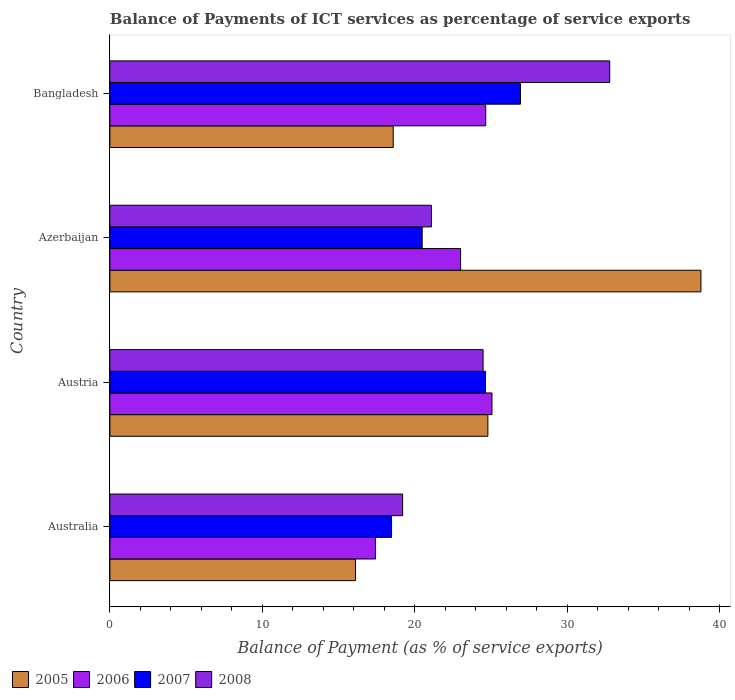How many different coloured bars are there?
Provide a succinct answer. 4. How many groups of bars are there?
Your response must be concise. 4. Are the number of bars per tick equal to the number of legend labels?
Give a very brief answer. Yes. How many bars are there on the 3rd tick from the bottom?
Give a very brief answer. 4. What is the label of the 1st group of bars from the top?
Give a very brief answer. Bangladesh. In how many cases, is the number of bars for a given country not equal to the number of legend labels?
Offer a very short reply. 0. What is the balance of payments of ICT services in 2006 in Azerbaijan?
Provide a succinct answer. 23. Across all countries, what is the maximum balance of payments of ICT services in 2006?
Ensure brevity in your answer.  25.06. Across all countries, what is the minimum balance of payments of ICT services in 2005?
Give a very brief answer. 16.11. In which country was the balance of payments of ICT services in 2006 maximum?
Your response must be concise. Austria. In which country was the balance of payments of ICT services in 2005 minimum?
Give a very brief answer. Australia. What is the total balance of payments of ICT services in 2008 in the graph?
Offer a terse response. 97.54. What is the difference between the balance of payments of ICT services in 2008 in Australia and that in Bangladesh?
Keep it short and to the point. -13.58. What is the difference between the balance of payments of ICT services in 2008 in Azerbaijan and the balance of payments of ICT services in 2006 in Australia?
Provide a short and direct response. 3.66. What is the average balance of payments of ICT services in 2006 per country?
Keep it short and to the point. 22.53. What is the difference between the balance of payments of ICT services in 2006 and balance of payments of ICT services in 2005 in Austria?
Offer a terse response. 0.27. In how many countries, is the balance of payments of ICT services in 2007 greater than 36 %?
Your answer should be compact. 0. What is the ratio of the balance of payments of ICT services in 2006 in Australia to that in Azerbaijan?
Provide a short and direct response. 0.76. Is the difference between the balance of payments of ICT services in 2006 in Austria and Azerbaijan greater than the difference between the balance of payments of ICT services in 2005 in Austria and Azerbaijan?
Provide a succinct answer. Yes. What is the difference between the highest and the second highest balance of payments of ICT services in 2007?
Provide a short and direct response. 2.3. What is the difference between the highest and the lowest balance of payments of ICT services in 2007?
Your response must be concise. 8.46. Is the sum of the balance of payments of ICT services in 2008 in Australia and Austria greater than the maximum balance of payments of ICT services in 2006 across all countries?
Offer a very short reply. Yes. How many countries are there in the graph?
Give a very brief answer. 4. What is the difference between two consecutive major ticks on the X-axis?
Your answer should be compact. 10. Are the values on the major ticks of X-axis written in scientific E-notation?
Ensure brevity in your answer.  No. Does the graph contain any zero values?
Your answer should be compact. No. How many legend labels are there?
Provide a succinct answer. 4. How are the legend labels stacked?
Keep it short and to the point. Horizontal. What is the title of the graph?
Ensure brevity in your answer.  Balance of Payments of ICT services as percentage of service exports. What is the label or title of the X-axis?
Offer a very short reply. Balance of Payment (as % of service exports). What is the Balance of Payment (as % of service exports) in 2005 in Australia?
Give a very brief answer. 16.11. What is the Balance of Payment (as % of service exports) in 2006 in Australia?
Make the answer very short. 17.42. What is the Balance of Payment (as % of service exports) in 2007 in Australia?
Make the answer very short. 18.47. What is the Balance of Payment (as % of service exports) of 2008 in Australia?
Your answer should be very brief. 19.2. What is the Balance of Payment (as % of service exports) of 2005 in Austria?
Your response must be concise. 24.79. What is the Balance of Payment (as % of service exports) of 2006 in Austria?
Provide a short and direct response. 25.06. What is the Balance of Payment (as % of service exports) in 2007 in Austria?
Your answer should be very brief. 24.63. What is the Balance of Payment (as % of service exports) of 2008 in Austria?
Offer a terse response. 24.47. What is the Balance of Payment (as % of service exports) in 2005 in Azerbaijan?
Provide a short and direct response. 38.76. What is the Balance of Payment (as % of service exports) in 2006 in Azerbaijan?
Offer a terse response. 23. What is the Balance of Payment (as % of service exports) in 2007 in Azerbaijan?
Give a very brief answer. 20.48. What is the Balance of Payment (as % of service exports) in 2008 in Azerbaijan?
Make the answer very short. 21.09. What is the Balance of Payment (as % of service exports) in 2005 in Bangladesh?
Provide a succinct answer. 18.58. What is the Balance of Payment (as % of service exports) of 2006 in Bangladesh?
Offer a terse response. 24.65. What is the Balance of Payment (as % of service exports) of 2007 in Bangladesh?
Keep it short and to the point. 26.93. What is the Balance of Payment (as % of service exports) in 2008 in Bangladesh?
Provide a succinct answer. 32.78. Across all countries, what is the maximum Balance of Payment (as % of service exports) of 2005?
Ensure brevity in your answer.  38.76. Across all countries, what is the maximum Balance of Payment (as % of service exports) in 2006?
Your response must be concise. 25.06. Across all countries, what is the maximum Balance of Payment (as % of service exports) in 2007?
Your response must be concise. 26.93. Across all countries, what is the maximum Balance of Payment (as % of service exports) of 2008?
Provide a short and direct response. 32.78. Across all countries, what is the minimum Balance of Payment (as % of service exports) of 2005?
Make the answer very short. 16.11. Across all countries, what is the minimum Balance of Payment (as % of service exports) in 2006?
Give a very brief answer. 17.42. Across all countries, what is the minimum Balance of Payment (as % of service exports) in 2007?
Provide a short and direct response. 18.47. Across all countries, what is the minimum Balance of Payment (as % of service exports) in 2008?
Offer a terse response. 19.2. What is the total Balance of Payment (as % of service exports) in 2005 in the graph?
Provide a short and direct response. 98.24. What is the total Balance of Payment (as % of service exports) in 2006 in the graph?
Provide a succinct answer. 90.12. What is the total Balance of Payment (as % of service exports) in 2007 in the graph?
Make the answer very short. 90.51. What is the total Balance of Payment (as % of service exports) of 2008 in the graph?
Ensure brevity in your answer.  97.54. What is the difference between the Balance of Payment (as % of service exports) in 2005 in Australia and that in Austria?
Give a very brief answer. -8.68. What is the difference between the Balance of Payment (as % of service exports) in 2006 in Australia and that in Austria?
Offer a terse response. -7.63. What is the difference between the Balance of Payment (as % of service exports) in 2007 in Australia and that in Austria?
Your answer should be very brief. -6.16. What is the difference between the Balance of Payment (as % of service exports) of 2008 in Australia and that in Austria?
Your response must be concise. -5.28. What is the difference between the Balance of Payment (as % of service exports) of 2005 in Australia and that in Azerbaijan?
Your answer should be very brief. -22.65. What is the difference between the Balance of Payment (as % of service exports) in 2006 in Australia and that in Azerbaijan?
Give a very brief answer. -5.58. What is the difference between the Balance of Payment (as % of service exports) of 2007 in Australia and that in Azerbaijan?
Provide a short and direct response. -2.01. What is the difference between the Balance of Payment (as % of service exports) of 2008 in Australia and that in Azerbaijan?
Make the answer very short. -1.89. What is the difference between the Balance of Payment (as % of service exports) of 2005 in Australia and that in Bangladesh?
Make the answer very short. -2.47. What is the difference between the Balance of Payment (as % of service exports) of 2006 in Australia and that in Bangladesh?
Your answer should be compact. -7.22. What is the difference between the Balance of Payment (as % of service exports) of 2007 in Australia and that in Bangladesh?
Your response must be concise. -8.46. What is the difference between the Balance of Payment (as % of service exports) of 2008 in Australia and that in Bangladesh?
Provide a succinct answer. -13.58. What is the difference between the Balance of Payment (as % of service exports) of 2005 in Austria and that in Azerbaijan?
Provide a succinct answer. -13.97. What is the difference between the Balance of Payment (as % of service exports) of 2006 in Austria and that in Azerbaijan?
Provide a short and direct response. 2.06. What is the difference between the Balance of Payment (as % of service exports) in 2007 in Austria and that in Azerbaijan?
Your answer should be compact. 4.15. What is the difference between the Balance of Payment (as % of service exports) of 2008 in Austria and that in Azerbaijan?
Offer a terse response. 3.39. What is the difference between the Balance of Payment (as % of service exports) of 2005 in Austria and that in Bangladesh?
Ensure brevity in your answer.  6.21. What is the difference between the Balance of Payment (as % of service exports) of 2006 in Austria and that in Bangladesh?
Provide a short and direct response. 0.41. What is the difference between the Balance of Payment (as % of service exports) of 2007 in Austria and that in Bangladesh?
Your answer should be very brief. -2.3. What is the difference between the Balance of Payment (as % of service exports) of 2008 in Austria and that in Bangladesh?
Ensure brevity in your answer.  -8.3. What is the difference between the Balance of Payment (as % of service exports) in 2005 in Azerbaijan and that in Bangladesh?
Keep it short and to the point. 20.18. What is the difference between the Balance of Payment (as % of service exports) in 2006 in Azerbaijan and that in Bangladesh?
Ensure brevity in your answer.  -1.65. What is the difference between the Balance of Payment (as % of service exports) in 2007 in Azerbaijan and that in Bangladesh?
Your response must be concise. -6.45. What is the difference between the Balance of Payment (as % of service exports) of 2008 in Azerbaijan and that in Bangladesh?
Your answer should be very brief. -11.69. What is the difference between the Balance of Payment (as % of service exports) in 2005 in Australia and the Balance of Payment (as % of service exports) in 2006 in Austria?
Offer a terse response. -8.95. What is the difference between the Balance of Payment (as % of service exports) of 2005 in Australia and the Balance of Payment (as % of service exports) of 2007 in Austria?
Ensure brevity in your answer.  -8.52. What is the difference between the Balance of Payment (as % of service exports) of 2005 in Australia and the Balance of Payment (as % of service exports) of 2008 in Austria?
Provide a short and direct response. -8.37. What is the difference between the Balance of Payment (as % of service exports) in 2006 in Australia and the Balance of Payment (as % of service exports) in 2007 in Austria?
Provide a short and direct response. -7.21. What is the difference between the Balance of Payment (as % of service exports) in 2006 in Australia and the Balance of Payment (as % of service exports) in 2008 in Austria?
Provide a short and direct response. -7.05. What is the difference between the Balance of Payment (as % of service exports) of 2007 in Australia and the Balance of Payment (as % of service exports) of 2008 in Austria?
Provide a short and direct response. -6. What is the difference between the Balance of Payment (as % of service exports) of 2005 in Australia and the Balance of Payment (as % of service exports) of 2006 in Azerbaijan?
Offer a terse response. -6.89. What is the difference between the Balance of Payment (as % of service exports) in 2005 in Australia and the Balance of Payment (as % of service exports) in 2007 in Azerbaijan?
Give a very brief answer. -4.37. What is the difference between the Balance of Payment (as % of service exports) in 2005 in Australia and the Balance of Payment (as % of service exports) in 2008 in Azerbaijan?
Provide a short and direct response. -4.98. What is the difference between the Balance of Payment (as % of service exports) in 2006 in Australia and the Balance of Payment (as % of service exports) in 2007 in Azerbaijan?
Make the answer very short. -3.06. What is the difference between the Balance of Payment (as % of service exports) of 2006 in Australia and the Balance of Payment (as % of service exports) of 2008 in Azerbaijan?
Your answer should be very brief. -3.66. What is the difference between the Balance of Payment (as % of service exports) of 2007 in Australia and the Balance of Payment (as % of service exports) of 2008 in Azerbaijan?
Your response must be concise. -2.61. What is the difference between the Balance of Payment (as % of service exports) of 2005 in Australia and the Balance of Payment (as % of service exports) of 2006 in Bangladesh?
Provide a short and direct response. -8.54. What is the difference between the Balance of Payment (as % of service exports) of 2005 in Australia and the Balance of Payment (as % of service exports) of 2007 in Bangladesh?
Your response must be concise. -10.82. What is the difference between the Balance of Payment (as % of service exports) of 2005 in Australia and the Balance of Payment (as % of service exports) of 2008 in Bangladesh?
Offer a very short reply. -16.67. What is the difference between the Balance of Payment (as % of service exports) in 2006 in Australia and the Balance of Payment (as % of service exports) in 2007 in Bangladesh?
Your answer should be very brief. -9.51. What is the difference between the Balance of Payment (as % of service exports) in 2006 in Australia and the Balance of Payment (as % of service exports) in 2008 in Bangladesh?
Offer a very short reply. -15.36. What is the difference between the Balance of Payment (as % of service exports) of 2007 in Australia and the Balance of Payment (as % of service exports) of 2008 in Bangladesh?
Your response must be concise. -14.31. What is the difference between the Balance of Payment (as % of service exports) in 2005 in Austria and the Balance of Payment (as % of service exports) in 2006 in Azerbaijan?
Your answer should be very brief. 1.79. What is the difference between the Balance of Payment (as % of service exports) in 2005 in Austria and the Balance of Payment (as % of service exports) in 2007 in Azerbaijan?
Ensure brevity in your answer.  4.31. What is the difference between the Balance of Payment (as % of service exports) of 2005 in Austria and the Balance of Payment (as % of service exports) of 2008 in Azerbaijan?
Make the answer very short. 3.7. What is the difference between the Balance of Payment (as % of service exports) in 2006 in Austria and the Balance of Payment (as % of service exports) in 2007 in Azerbaijan?
Make the answer very short. 4.58. What is the difference between the Balance of Payment (as % of service exports) of 2006 in Austria and the Balance of Payment (as % of service exports) of 2008 in Azerbaijan?
Provide a short and direct response. 3.97. What is the difference between the Balance of Payment (as % of service exports) in 2007 in Austria and the Balance of Payment (as % of service exports) in 2008 in Azerbaijan?
Provide a short and direct response. 3.55. What is the difference between the Balance of Payment (as % of service exports) in 2005 in Austria and the Balance of Payment (as % of service exports) in 2006 in Bangladesh?
Your response must be concise. 0.14. What is the difference between the Balance of Payment (as % of service exports) of 2005 in Austria and the Balance of Payment (as % of service exports) of 2007 in Bangladesh?
Provide a succinct answer. -2.14. What is the difference between the Balance of Payment (as % of service exports) in 2005 in Austria and the Balance of Payment (as % of service exports) in 2008 in Bangladesh?
Keep it short and to the point. -7.99. What is the difference between the Balance of Payment (as % of service exports) in 2006 in Austria and the Balance of Payment (as % of service exports) in 2007 in Bangladesh?
Your response must be concise. -1.87. What is the difference between the Balance of Payment (as % of service exports) of 2006 in Austria and the Balance of Payment (as % of service exports) of 2008 in Bangladesh?
Your response must be concise. -7.72. What is the difference between the Balance of Payment (as % of service exports) of 2007 in Austria and the Balance of Payment (as % of service exports) of 2008 in Bangladesh?
Provide a succinct answer. -8.14. What is the difference between the Balance of Payment (as % of service exports) of 2005 in Azerbaijan and the Balance of Payment (as % of service exports) of 2006 in Bangladesh?
Offer a terse response. 14.12. What is the difference between the Balance of Payment (as % of service exports) in 2005 in Azerbaijan and the Balance of Payment (as % of service exports) in 2007 in Bangladesh?
Provide a short and direct response. 11.83. What is the difference between the Balance of Payment (as % of service exports) of 2005 in Azerbaijan and the Balance of Payment (as % of service exports) of 2008 in Bangladesh?
Provide a short and direct response. 5.98. What is the difference between the Balance of Payment (as % of service exports) of 2006 in Azerbaijan and the Balance of Payment (as % of service exports) of 2007 in Bangladesh?
Your answer should be very brief. -3.93. What is the difference between the Balance of Payment (as % of service exports) of 2006 in Azerbaijan and the Balance of Payment (as % of service exports) of 2008 in Bangladesh?
Your answer should be compact. -9.78. What is the difference between the Balance of Payment (as % of service exports) in 2007 in Azerbaijan and the Balance of Payment (as % of service exports) in 2008 in Bangladesh?
Make the answer very short. -12.3. What is the average Balance of Payment (as % of service exports) in 2005 per country?
Give a very brief answer. 24.56. What is the average Balance of Payment (as % of service exports) in 2006 per country?
Make the answer very short. 22.53. What is the average Balance of Payment (as % of service exports) of 2007 per country?
Offer a very short reply. 22.63. What is the average Balance of Payment (as % of service exports) in 2008 per country?
Your response must be concise. 24.38. What is the difference between the Balance of Payment (as % of service exports) of 2005 and Balance of Payment (as % of service exports) of 2006 in Australia?
Ensure brevity in your answer.  -1.31. What is the difference between the Balance of Payment (as % of service exports) in 2005 and Balance of Payment (as % of service exports) in 2007 in Australia?
Offer a very short reply. -2.36. What is the difference between the Balance of Payment (as % of service exports) in 2005 and Balance of Payment (as % of service exports) in 2008 in Australia?
Offer a terse response. -3.09. What is the difference between the Balance of Payment (as % of service exports) of 2006 and Balance of Payment (as % of service exports) of 2007 in Australia?
Your answer should be compact. -1.05. What is the difference between the Balance of Payment (as % of service exports) in 2006 and Balance of Payment (as % of service exports) in 2008 in Australia?
Offer a terse response. -1.78. What is the difference between the Balance of Payment (as % of service exports) of 2007 and Balance of Payment (as % of service exports) of 2008 in Australia?
Your answer should be very brief. -0.73. What is the difference between the Balance of Payment (as % of service exports) in 2005 and Balance of Payment (as % of service exports) in 2006 in Austria?
Offer a very short reply. -0.27. What is the difference between the Balance of Payment (as % of service exports) in 2005 and Balance of Payment (as % of service exports) in 2007 in Austria?
Make the answer very short. 0.16. What is the difference between the Balance of Payment (as % of service exports) of 2005 and Balance of Payment (as % of service exports) of 2008 in Austria?
Ensure brevity in your answer.  0.31. What is the difference between the Balance of Payment (as % of service exports) of 2006 and Balance of Payment (as % of service exports) of 2007 in Austria?
Give a very brief answer. 0.42. What is the difference between the Balance of Payment (as % of service exports) of 2006 and Balance of Payment (as % of service exports) of 2008 in Austria?
Your answer should be compact. 0.58. What is the difference between the Balance of Payment (as % of service exports) in 2007 and Balance of Payment (as % of service exports) in 2008 in Austria?
Your answer should be very brief. 0.16. What is the difference between the Balance of Payment (as % of service exports) in 2005 and Balance of Payment (as % of service exports) in 2006 in Azerbaijan?
Offer a very short reply. 15.76. What is the difference between the Balance of Payment (as % of service exports) of 2005 and Balance of Payment (as % of service exports) of 2007 in Azerbaijan?
Offer a terse response. 18.28. What is the difference between the Balance of Payment (as % of service exports) of 2005 and Balance of Payment (as % of service exports) of 2008 in Azerbaijan?
Keep it short and to the point. 17.68. What is the difference between the Balance of Payment (as % of service exports) in 2006 and Balance of Payment (as % of service exports) in 2007 in Azerbaijan?
Ensure brevity in your answer.  2.52. What is the difference between the Balance of Payment (as % of service exports) in 2006 and Balance of Payment (as % of service exports) in 2008 in Azerbaijan?
Provide a short and direct response. 1.91. What is the difference between the Balance of Payment (as % of service exports) in 2007 and Balance of Payment (as % of service exports) in 2008 in Azerbaijan?
Make the answer very short. -0.61. What is the difference between the Balance of Payment (as % of service exports) in 2005 and Balance of Payment (as % of service exports) in 2006 in Bangladesh?
Make the answer very short. -6.07. What is the difference between the Balance of Payment (as % of service exports) in 2005 and Balance of Payment (as % of service exports) in 2007 in Bangladesh?
Offer a very short reply. -8.35. What is the difference between the Balance of Payment (as % of service exports) in 2005 and Balance of Payment (as % of service exports) in 2008 in Bangladesh?
Ensure brevity in your answer.  -14.2. What is the difference between the Balance of Payment (as % of service exports) of 2006 and Balance of Payment (as % of service exports) of 2007 in Bangladesh?
Your response must be concise. -2.28. What is the difference between the Balance of Payment (as % of service exports) in 2006 and Balance of Payment (as % of service exports) in 2008 in Bangladesh?
Provide a succinct answer. -8.13. What is the difference between the Balance of Payment (as % of service exports) of 2007 and Balance of Payment (as % of service exports) of 2008 in Bangladesh?
Ensure brevity in your answer.  -5.85. What is the ratio of the Balance of Payment (as % of service exports) of 2005 in Australia to that in Austria?
Keep it short and to the point. 0.65. What is the ratio of the Balance of Payment (as % of service exports) of 2006 in Australia to that in Austria?
Give a very brief answer. 0.7. What is the ratio of the Balance of Payment (as % of service exports) of 2007 in Australia to that in Austria?
Keep it short and to the point. 0.75. What is the ratio of the Balance of Payment (as % of service exports) of 2008 in Australia to that in Austria?
Provide a succinct answer. 0.78. What is the ratio of the Balance of Payment (as % of service exports) of 2005 in Australia to that in Azerbaijan?
Offer a terse response. 0.42. What is the ratio of the Balance of Payment (as % of service exports) in 2006 in Australia to that in Azerbaijan?
Keep it short and to the point. 0.76. What is the ratio of the Balance of Payment (as % of service exports) in 2007 in Australia to that in Azerbaijan?
Your answer should be compact. 0.9. What is the ratio of the Balance of Payment (as % of service exports) in 2008 in Australia to that in Azerbaijan?
Your answer should be compact. 0.91. What is the ratio of the Balance of Payment (as % of service exports) of 2005 in Australia to that in Bangladesh?
Keep it short and to the point. 0.87. What is the ratio of the Balance of Payment (as % of service exports) in 2006 in Australia to that in Bangladesh?
Ensure brevity in your answer.  0.71. What is the ratio of the Balance of Payment (as % of service exports) of 2007 in Australia to that in Bangladesh?
Your answer should be compact. 0.69. What is the ratio of the Balance of Payment (as % of service exports) of 2008 in Australia to that in Bangladesh?
Ensure brevity in your answer.  0.59. What is the ratio of the Balance of Payment (as % of service exports) of 2005 in Austria to that in Azerbaijan?
Give a very brief answer. 0.64. What is the ratio of the Balance of Payment (as % of service exports) in 2006 in Austria to that in Azerbaijan?
Your answer should be compact. 1.09. What is the ratio of the Balance of Payment (as % of service exports) of 2007 in Austria to that in Azerbaijan?
Make the answer very short. 1.2. What is the ratio of the Balance of Payment (as % of service exports) in 2008 in Austria to that in Azerbaijan?
Give a very brief answer. 1.16. What is the ratio of the Balance of Payment (as % of service exports) in 2005 in Austria to that in Bangladesh?
Your answer should be compact. 1.33. What is the ratio of the Balance of Payment (as % of service exports) in 2006 in Austria to that in Bangladesh?
Give a very brief answer. 1.02. What is the ratio of the Balance of Payment (as % of service exports) in 2007 in Austria to that in Bangladesh?
Provide a succinct answer. 0.91. What is the ratio of the Balance of Payment (as % of service exports) in 2008 in Austria to that in Bangladesh?
Ensure brevity in your answer.  0.75. What is the ratio of the Balance of Payment (as % of service exports) of 2005 in Azerbaijan to that in Bangladesh?
Give a very brief answer. 2.09. What is the ratio of the Balance of Payment (as % of service exports) in 2006 in Azerbaijan to that in Bangladesh?
Offer a terse response. 0.93. What is the ratio of the Balance of Payment (as % of service exports) in 2007 in Azerbaijan to that in Bangladesh?
Make the answer very short. 0.76. What is the ratio of the Balance of Payment (as % of service exports) in 2008 in Azerbaijan to that in Bangladesh?
Provide a short and direct response. 0.64. What is the difference between the highest and the second highest Balance of Payment (as % of service exports) of 2005?
Make the answer very short. 13.97. What is the difference between the highest and the second highest Balance of Payment (as % of service exports) of 2006?
Provide a succinct answer. 0.41. What is the difference between the highest and the second highest Balance of Payment (as % of service exports) of 2007?
Offer a terse response. 2.3. What is the difference between the highest and the second highest Balance of Payment (as % of service exports) in 2008?
Provide a short and direct response. 8.3. What is the difference between the highest and the lowest Balance of Payment (as % of service exports) in 2005?
Provide a short and direct response. 22.65. What is the difference between the highest and the lowest Balance of Payment (as % of service exports) in 2006?
Provide a short and direct response. 7.63. What is the difference between the highest and the lowest Balance of Payment (as % of service exports) in 2007?
Your answer should be very brief. 8.46. What is the difference between the highest and the lowest Balance of Payment (as % of service exports) in 2008?
Give a very brief answer. 13.58. 